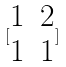Convert formula to latex. <formula><loc_0><loc_0><loc_500><loc_500>[ \begin{matrix} 1 & 2 \\ 1 & 1 \end{matrix} ]</formula> 